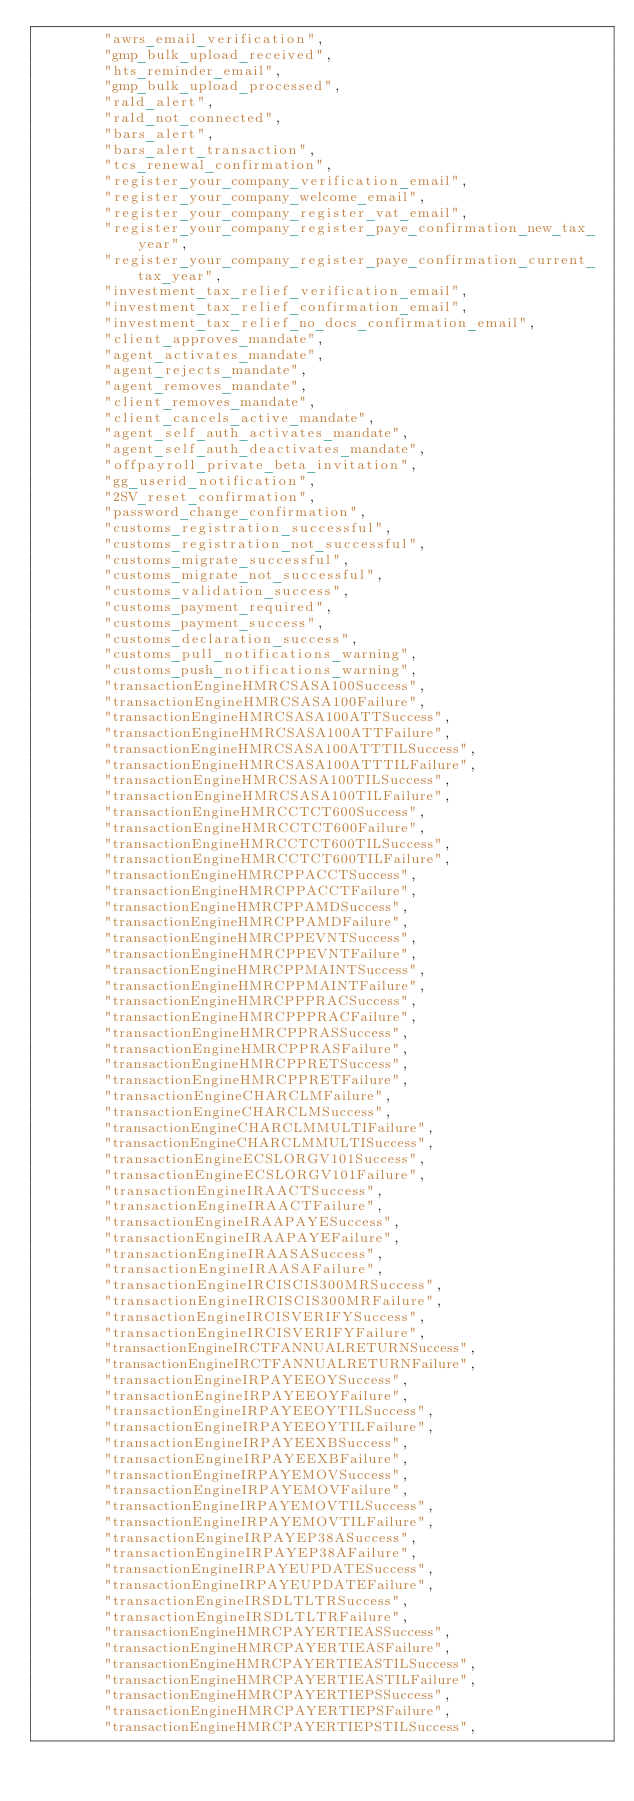<code> <loc_0><loc_0><loc_500><loc_500><_Scala_>        "awrs_email_verification",
        "gmp_bulk_upload_received",
        "hts_reminder_email",
        "gmp_bulk_upload_processed",
        "rald_alert",
        "rald_not_connected",
        "bars_alert",
        "bars_alert_transaction",
        "tcs_renewal_confirmation",
        "register_your_company_verification_email",
        "register_your_company_welcome_email",
        "register_your_company_register_vat_email",
        "register_your_company_register_paye_confirmation_new_tax_year",
        "register_your_company_register_paye_confirmation_current_tax_year",
        "investment_tax_relief_verification_email",
        "investment_tax_relief_confirmation_email",
        "investment_tax_relief_no_docs_confirmation_email",
        "client_approves_mandate",
        "agent_activates_mandate",
        "agent_rejects_mandate",
        "agent_removes_mandate",
        "client_removes_mandate",
        "client_cancels_active_mandate",
        "agent_self_auth_activates_mandate",
        "agent_self_auth_deactivates_mandate",
        "offpayroll_private_beta_invitation",
        "gg_userid_notification",
        "2SV_reset_confirmation",
        "password_change_confirmation",
        "customs_registration_successful",
        "customs_registration_not_successful",
        "customs_migrate_successful",
        "customs_migrate_not_successful",
        "customs_validation_success",
        "customs_payment_required",
        "customs_payment_success",
        "customs_declaration_success",
        "customs_pull_notifications_warning",
        "customs_push_notifications_warning",
        "transactionEngineHMRCSASA100Success",
        "transactionEngineHMRCSASA100Failure",
        "transactionEngineHMRCSASA100ATTSuccess",
        "transactionEngineHMRCSASA100ATTFailure",
        "transactionEngineHMRCSASA100ATTTILSuccess",
        "transactionEngineHMRCSASA100ATTTILFailure",
        "transactionEngineHMRCSASA100TILSuccess",
        "transactionEngineHMRCSASA100TILFailure",
        "transactionEngineHMRCCTCT600Success",
        "transactionEngineHMRCCTCT600Failure",
        "transactionEngineHMRCCTCT600TILSuccess",
        "transactionEngineHMRCCTCT600TILFailure",
        "transactionEngineHMRCPPACCTSuccess",
        "transactionEngineHMRCPPACCTFailure",
        "transactionEngineHMRCPPAMDSuccess",
        "transactionEngineHMRCPPAMDFailure",
        "transactionEngineHMRCPPEVNTSuccess",
        "transactionEngineHMRCPPEVNTFailure",
        "transactionEngineHMRCPPMAINTSuccess",
        "transactionEngineHMRCPPMAINTFailure",
        "transactionEngineHMRCPPPRACSuccess",
        "transactionEngineHMRCPPPRACFailure",
        "transactionEngineHMRCPPRASSuccess",
        "transactionEngineHMRCPPRASFailure",
        "transactionEngineHMRCPPRETSuccess",
        "transactionEngineHMRCPPRETFailure",
        "transactionEngineCHARCLMFailure",
        "transactionEngineCHARCLMSuccess",
        "transactionEngineCHARCLMMULTIFailure",
        "transactionEngineCHARCLMMULTISuccess",
        "transactionEngineECSLORGV101Success",
        "transactionEngineECSLORGV101Failure",
        "transactionEngineIRAACTSuccess",
        "transactionEngineIRAACTFailure",
        "transactionEngineIRAAPAYESuccess",
        "transactionEngineIRAAPAYEFailure",
        "transactionEngineIRAASASuccess",
        "transactionEngineIRAASAFailure",
        "transactionEngineIRCISCIS300MRSuccess",
        "transactionEngineIRCISCIS300MRFailure",
        "transactionEngineIRCISVERIFYSuccess",
        "transactionEngineIRCISVERIFYFailure",
        "transactionEngineIRCTFANNUALRETURNSuccess",
        "transactionEngineIRCTFANNUALRETURNFailure",
        "transactionEngineIRPAYEEOYSuccess",
        "transactionEngineIRPAYEEOYFailure",
        "transactionEngineIRPAYEEOYTILSuccess",
        "transactionEngineIRPAYEEOYTILFailure",
        "transactionEngineIRPAYEEXBSuccess",
        "transactionEngineIRPAYEEXBFailure",
        "transactionEngineIRPAYEMOVSuccess",
        "transactionEngineIRPAYEMOVFailure",
        "transactionEngineIRPAYEMOVTILSuccess",
        "transactionEngineIRPAYEMOVTILFailure",
        "transactionEngineIRPAYEP38ASuccess",
        "transactionEngineIRPAYEP38AFailure",
        "transactionEngineIRPAYEUPDATESuccess",
        "transactionEngineIRPAYEUPDATEFailure",
        "transactionEngineIRSDLTLTRSuccess",
        "transactionEngineIRSDLTLTRFailure",
        "transactionEngineHMRCPAYERTIEASSuccess",
        "transactionEngineHMRCPAYERTIEASFailure",
        "transactionEngineHMRCPAYERTIEASTILSuccess",
        "transactionEngineHMRCPAYERTIEASTILFailure",
        "transactionEngineHMRCPAYERTIEPSSuccess",
        "transactionEngineHMRCPAYERTIEPSFailure",
        "transactionEngineHMRCPAYERTIEPSTILSuccess",</code> 